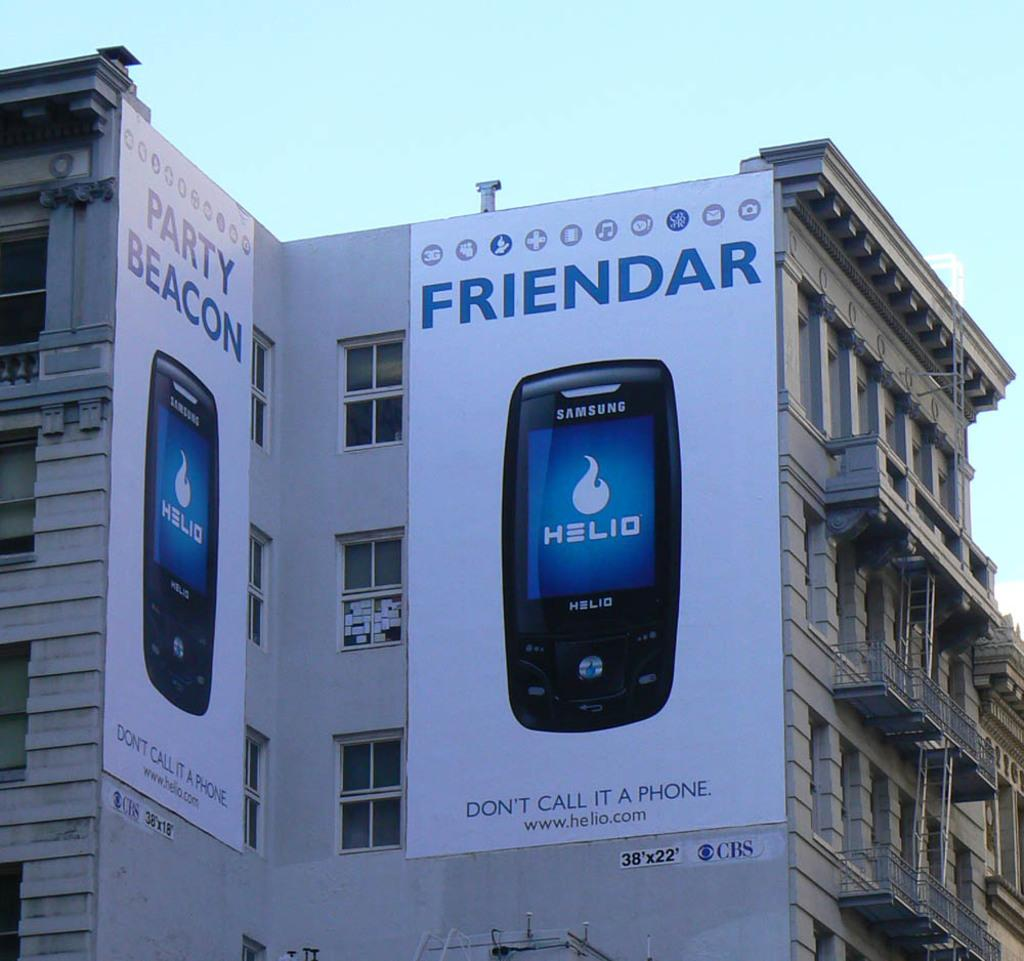<image>
Write a terse but informative summary of the picture. An advertisement poster for a phone company named Friendar. 